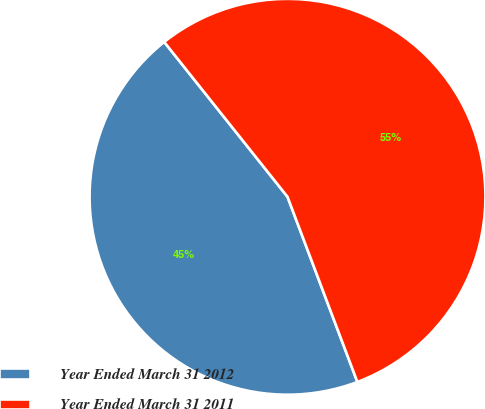Convert chart to OTSL. <chart><loc_0><loc_0><loc_500><loc_500><pie_chart><fcel>Year Ended March 31 2012<fcel>Year Ended March 31 2011<nl><fcel>45.04%<fcel>54.96%<nl></chart> 